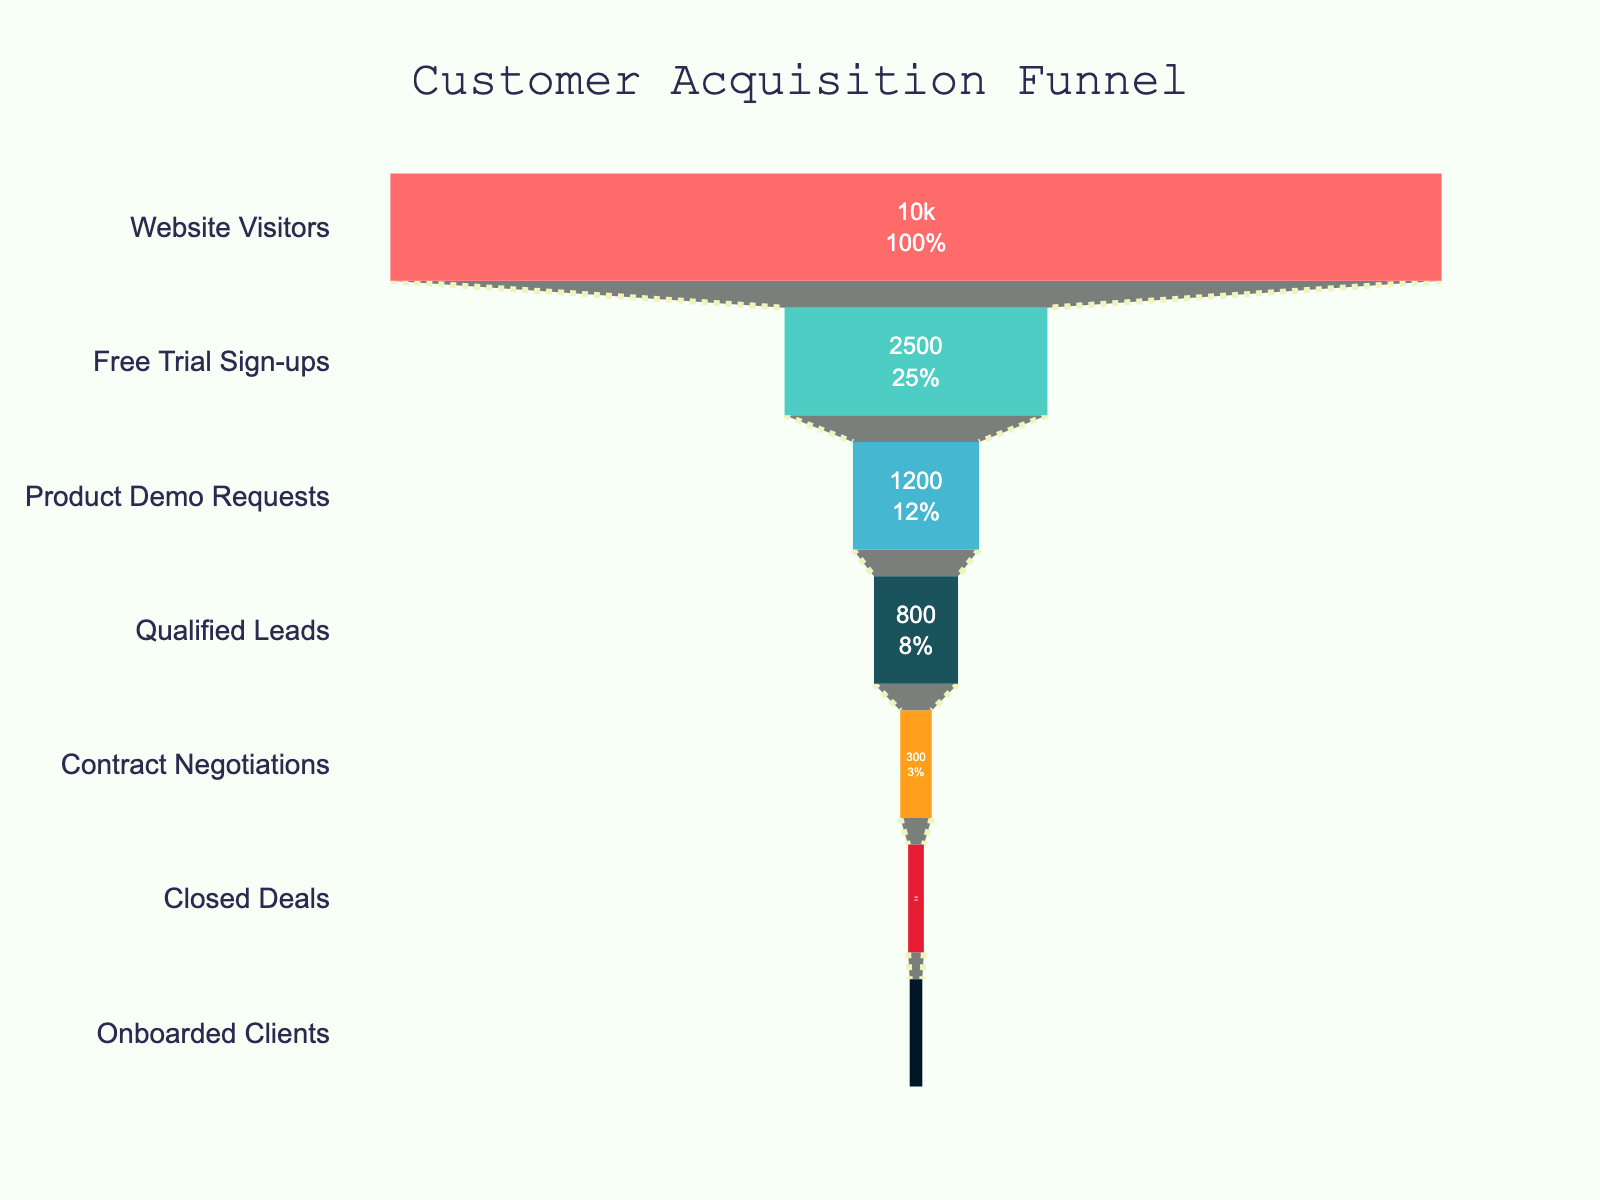What is the title of the chart? The title is located at the top of the chart, written in a large font size with distinct color. It reads 'Customer Acquisition Funnel'.
Answer: Customer Acquisition Funnel How many stages are represented in the funnel? By counting the individual segments of the funnel, you can see there are seven stages listed from top to bottom.
Answer: Seven Which stage has the highest number of customers? The highest number of customers is represented by the widest segment at the top of the funnel, labeled as 'Website Visitors' with 10,000 customers.
Answer: Website Visitors What's the value for 'Closed Deals'? From the list of stages and their corresponding values, 'Closed Deals' shows 150 customers.
Answer: 150 What percentage of 'Qualified Leads' convert to 'Closed Deals'? Divide 'Closed Deals' (150) by 'Qualified Leads' (800), then multiply by 100 to get the percentage. 150 / 800 * 100 = 18.75%.
Answer: 18.75% How many customers drop off from 'Product Demo Requests' to 'Qualified Leads'? Subtract the number of 'Qualified Leads' (800) from 'Product Demo Requests' (1200) to find the drop-off. 1200 - 800 = 400.
Answer: 400 Which stage has a larger number of customers, 'Free Trial Sign-ups' or 'Product Demo Requests'? Compare the values of 'Free Trial Sign-ups' (2500) and 'Product Demo Requests' (1200). 2500 is greater than 1200.
Answer: Free Trial Sign-ups What's the difference in customers between 'Contract Negotiations' and 'Onboarded Clients'? Subtract 'Onboarded Clients' (120) from 'Contract Negotiations' (300). 300 - 120 = 180.
Answer: 180 What fraction of 'Website Visitors' sign up for a free trial? Divide 'Free Trial Sign-ups' (2500) by 'Website Visitors' (10000) to get the fraction. 2500 / 10000 = 1/4 or 0.25.
Answer: 0.25 or 1/4 How many customers total convert from 'Website Visitors' to 'Onboarded Clients'? 'Onboarded Clients' (120) is the final stage, representing those who converted from 'Website Visitors' (10000) through each funnel stage to the end.
Answer: 120 